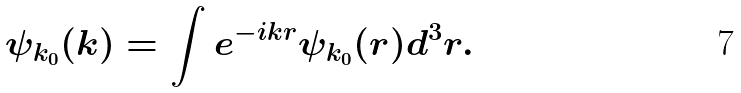<formula> <loc_0><loc_0><loc_500><loc_500>\psi _ { k _ { 0 } } ( { k } ) = \int e ^ { - i { k r } } \psi _ { k _ { 0 } } ( { r } ) d ^ { 3 } r .</formula> 